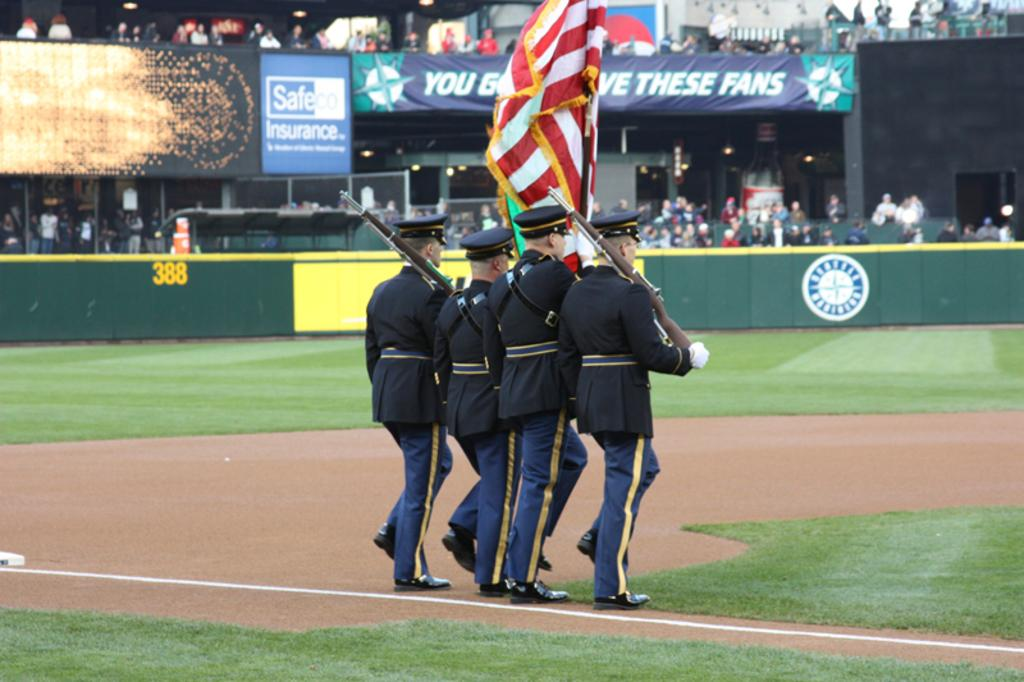Provide a one-sentence caption for the provided image. Square blue and white sign with Safeco on it. 